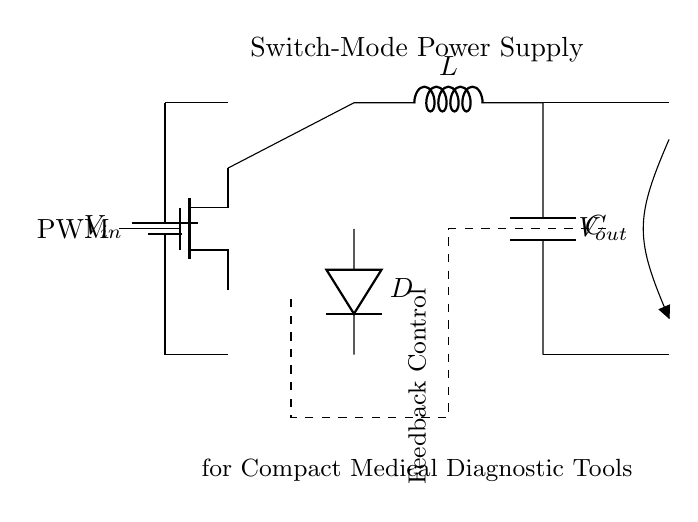What is the input voltage of this circuit? The circuit contains a battery symbol labeled as V_in, which indicates the input voltage, but the exact value isn't provided in the diagram.
Answer: V_in What component is used to store energy in the circuit? The inductor, labeled as L, is the component that stores energy in the circuit during the on-time of the MOSFET.
Answer: Inductor What does PWM stand for in this circuit? PWM stands for Pulse Width Modulation, which controls the MOSFET's switching behavior to regulate the output voltage.
Answer: Pulse Width Modulation How many main energy storage components are in this circuit? There are two main energy storage components: the inductor (L) and the capacitor (C).
Answer: Two What is the function of the diode labeled D? The diode allows current to flow in one direction only, which is essential for ensuring that the output voltage does not drop below a certain level when the MOSFET is off.
Answer: Prevents backflow What is the purpose of the feedback control in this circuit? The feedback control is used to monitor the output voltage and adjust the PWM signal accordingly to maintain a stable output despite variations in input or load conditions.
Answer: Voltage regulation 